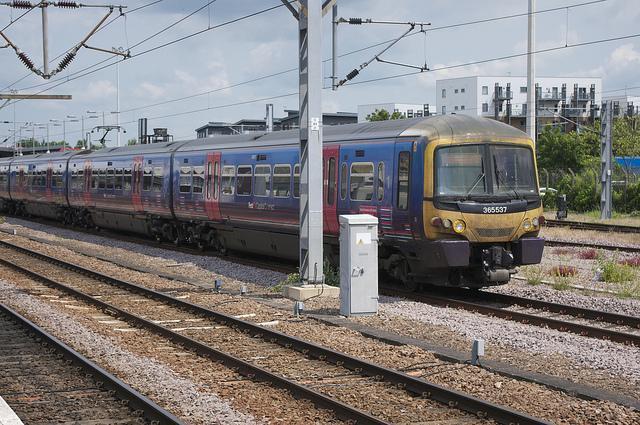How many TV trays are there?
Give a very brief answer. 0. 